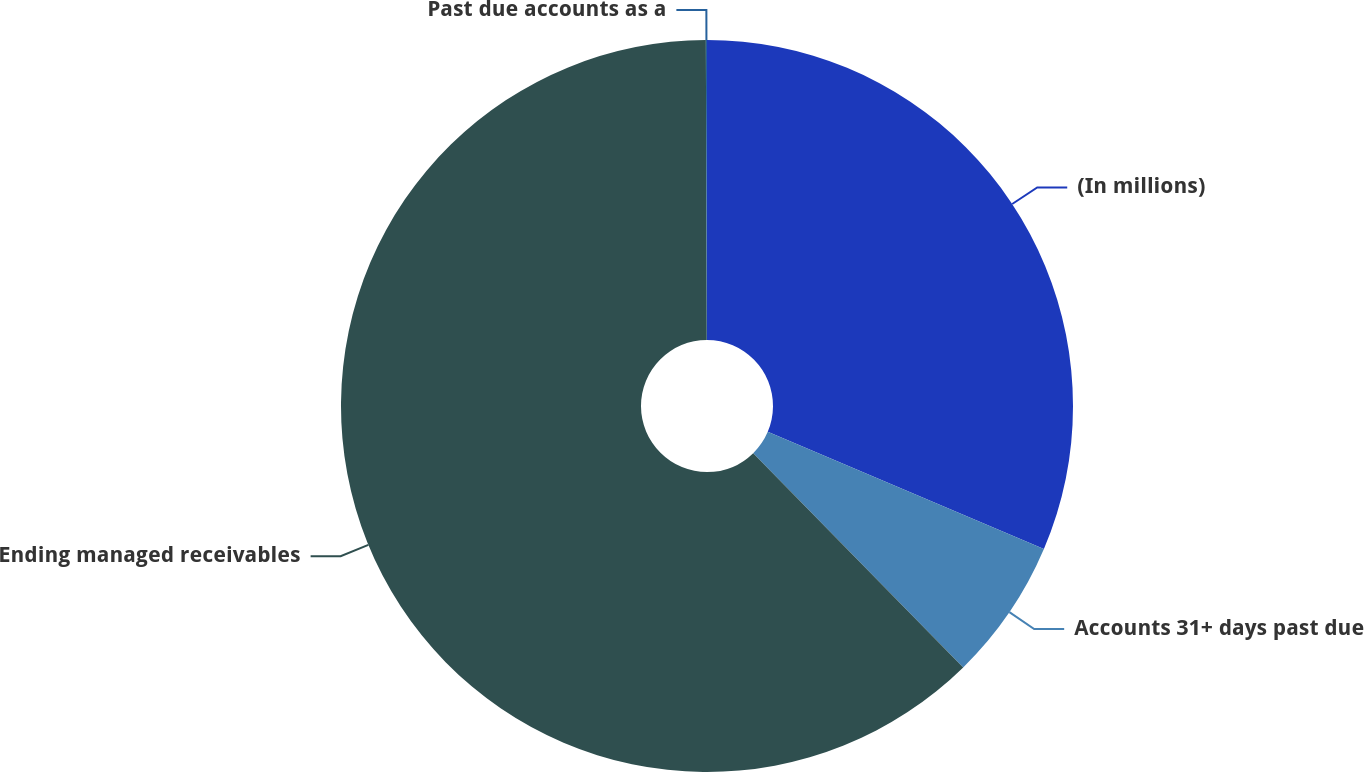Convert chart. <chart><loc_0><loc_0><loc_500><loc_500><pie_chart><fcel>(In millions)<fcel>Accounts 31+ days past due<fcel>Ending managed receivables<fcel>Past due accounts as a<nl><fcel>31.39%<fcel>6.27%<fcel>62.29%<fcel>0.05%<nl></chart> 